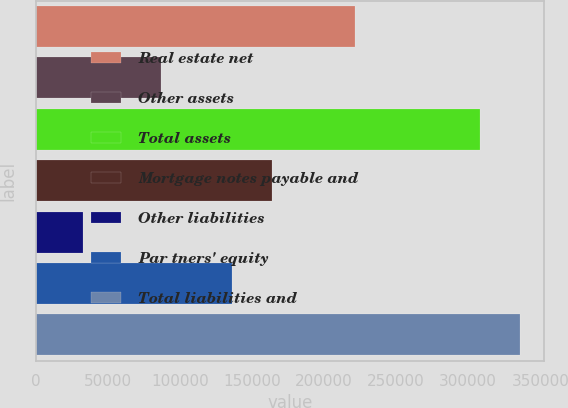<chart> <loc_0><loc_0><loc_500><loc_500><bar_chart><fcel>Real estate net<fcel>Other assets<fcel>Total assets<fcel>Mortgage notes payable and<fcel>Other liabilities<fcel>Par tners' equity<fcel>Total liabilities and<nl><fcel>221236<fcel>86821<fcel>308057<fcel>163526<fcel>32579<fcel>135978<fcel>335605<nl></chart> 